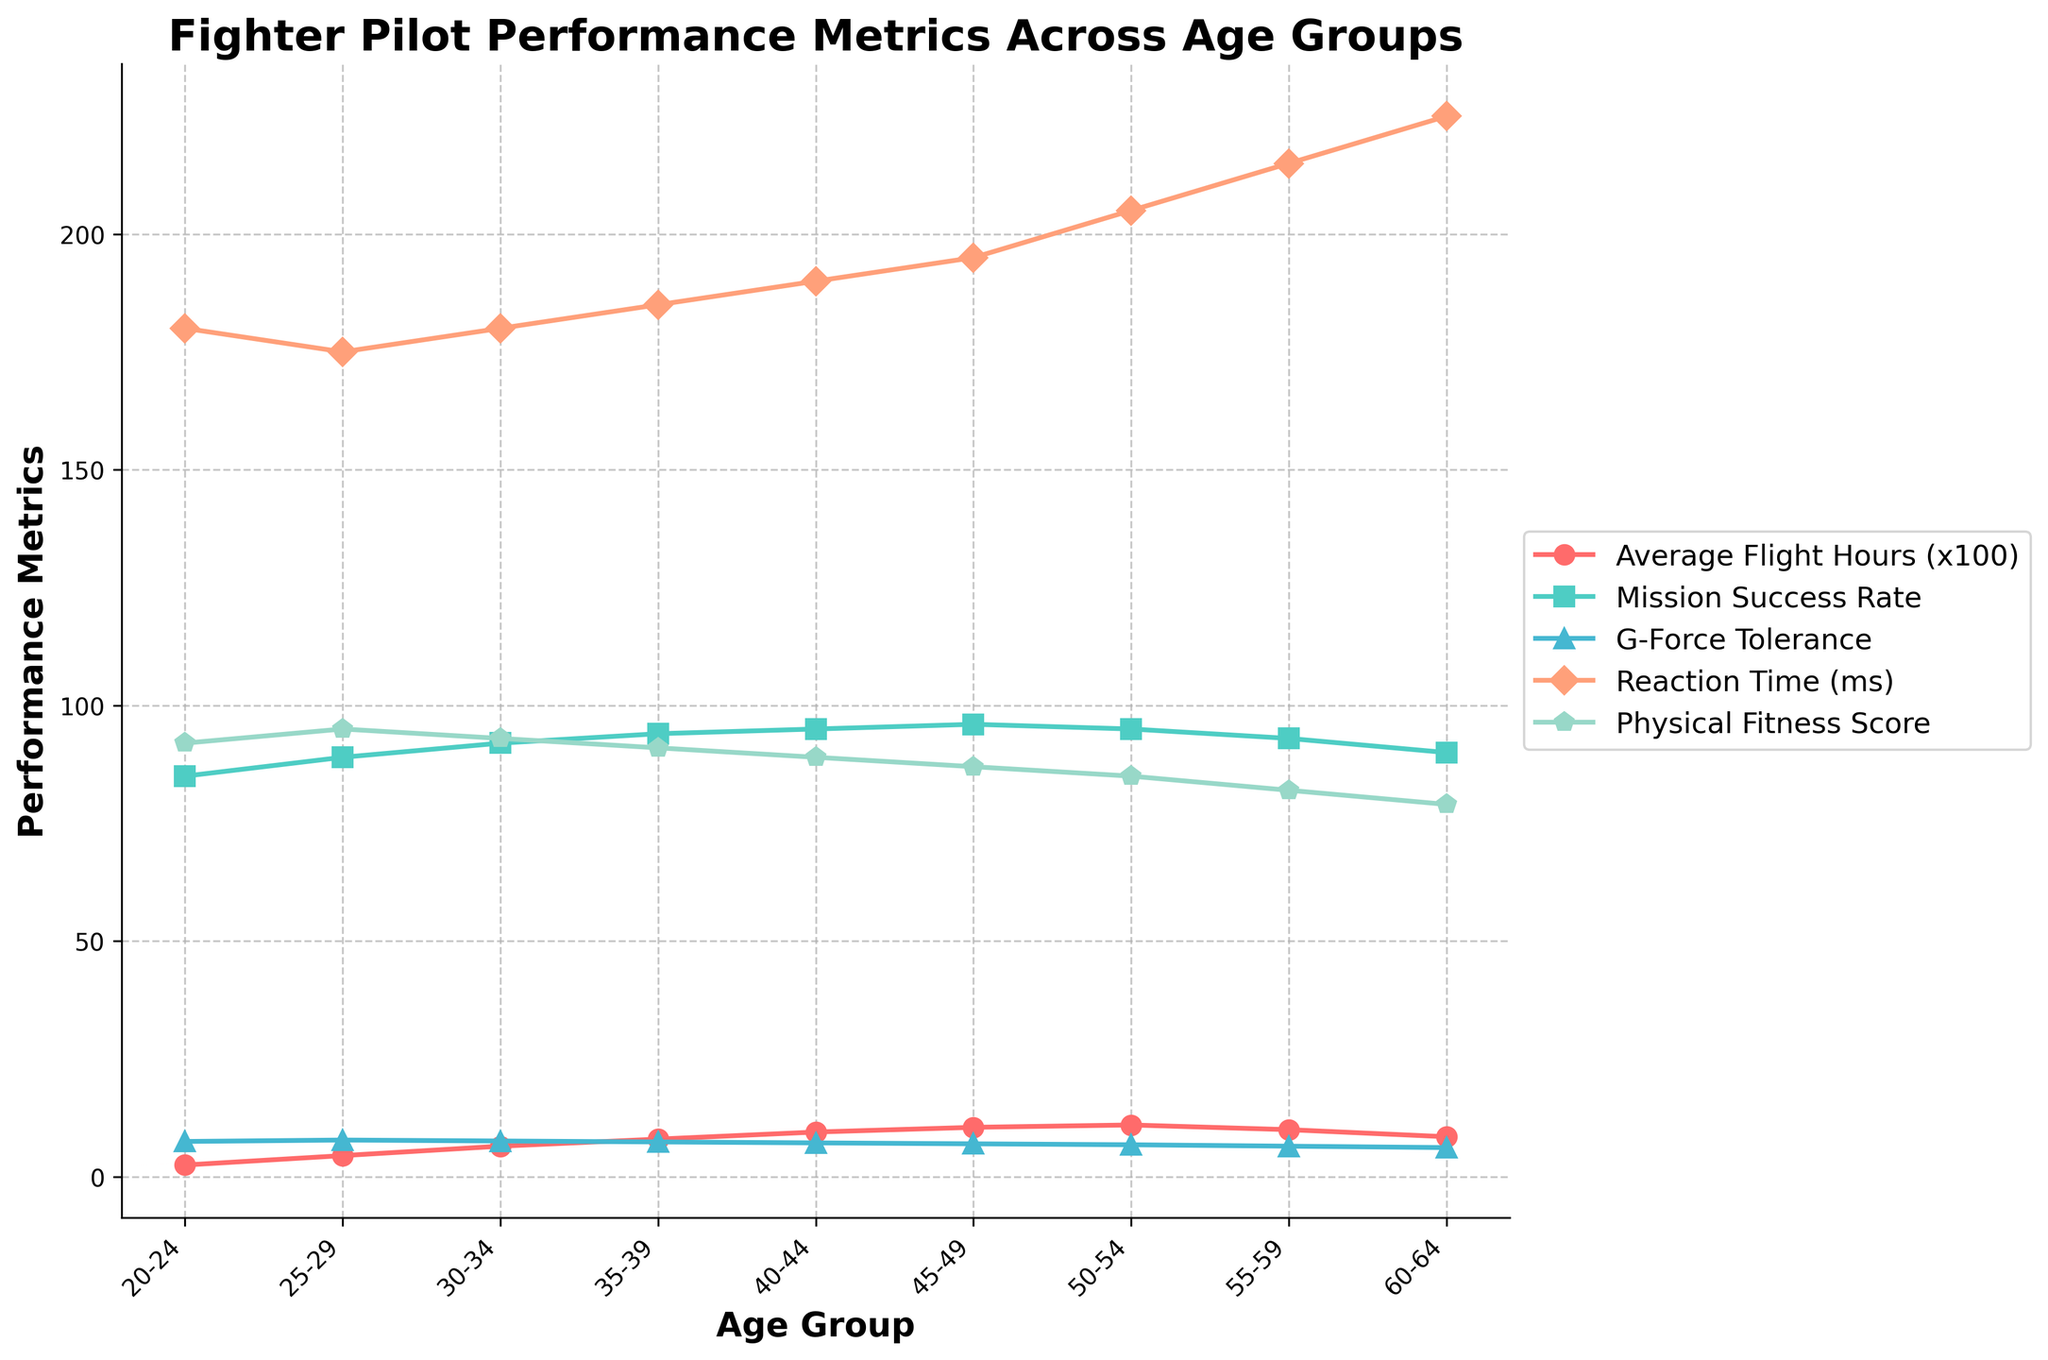What's the trend of Average Flight Hours as age increases? As age increases from the 20-24 group to the 50-54 group, Average Flight Hours consistently rise, peaking at the 50-54 age group, and then they start decreasing in the 55-59 and 60-64 groups.
Answer: Increases then decreases How does Mission Success Rate vary with age? Mission Success Rate increases from 85 in the 20-24 age group to 96 in the 45-49 age group. It then slightly decreases to 95 for the 50-54 age group and continues decreasing to 90 in the 60-64 age group.
Answer: Increases then decreases Which age group has the highest G-Force Tolerance? The highest G-Force Tolerance is 7.8, which occurs in the 25-29 age group.
Answer: 25-29 How does Reaction Time change as age increases from 20-24 to 60-64? Reaction Time starts at 180 ms in the 20-24 age group and steadily increases at each age interval, reaching 225 ms in the 60-64 age group.
Answer: Increases What is the difference in Physical Fitness Score between the 25-29 and 55-59 age groups? The Physical Fitness Score for the 25-29 age group is 95, and for the 55-59 age group, it is 82. The difference is 95 - 82 = 13.
Answer: 13 Which performance metric shows a consistent decreasing trend with age? G-Force Tolerance and Physical Fitness Score both show consistent decreasing trends as age increases across all age groups.
Answer: G-Force Tolerance and Physical Fitness Score Compare the Mission Success Rate between the youngest and oldest age groups. The Mission Success Rate for the 20-24 age group is 85, while for the 60-64 age group, it is 90. Hence, the oldest age group has a higher Mission Success Rate than the youngest.
Answer: Oldest has higher What is the average Mission Success Rate across all age groups? Summing up the Mission Success Rates (85 + 89 +92 + 94 + 95 + 96 + 95 + 93 + 90) gives 829. There are 9 age groups, so the average is 829 / 9 ≈ 92.1.
Answer: Approximately 92.1 What's the difference in Reaction Time between the age groups with the lowest and highest Average Flight Hours? The age group 20-24 has the lowest Average Flight Hours with Reaction Time of 180 ms. The age group 50-54 has the highest Average Flight Hours with Reaction Time of 205 ms. The difference is 205 - 180 = 25 ms.
Answer: 25 ms 